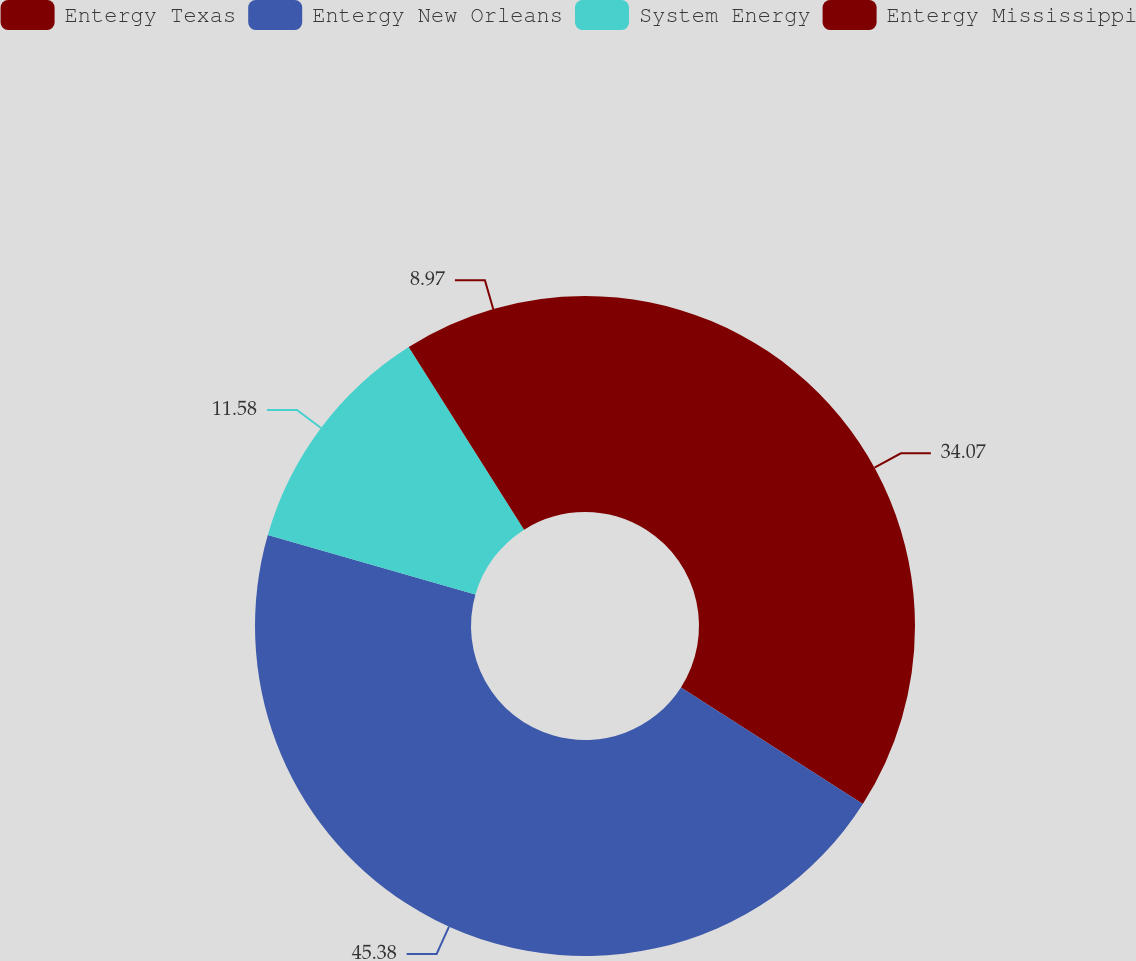<chart> <loc_0><loc_0><loc_500><loc_500><pie_chart><fcel>Entergy Texas<fcel>Entergy New Orleans<fcel>System Energy<fcel>Entergy Mississippi<nl><fcel>34.07%<fcel>45.38%<fcel>11.58%<fcel>8.97%<nl></chart> 